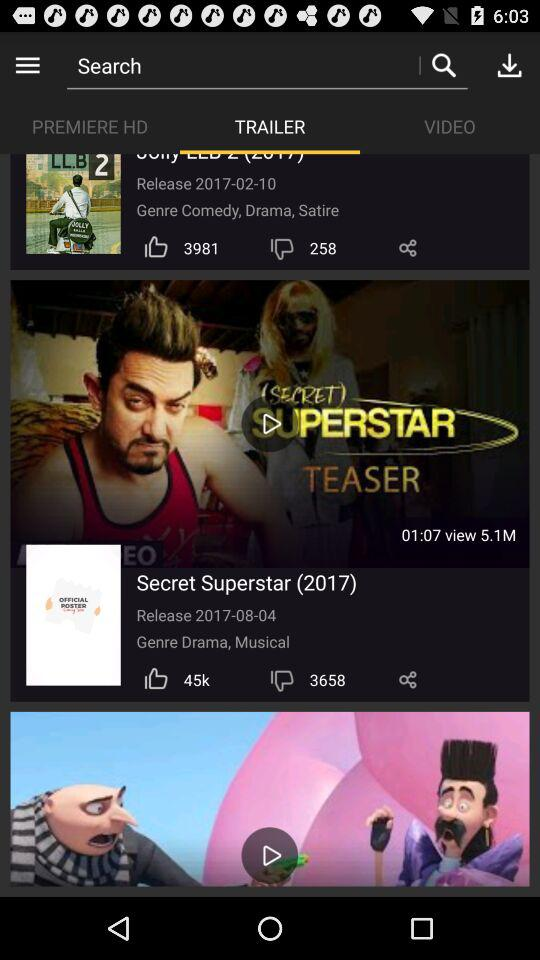What is the release date of the Secret Superstar? The release date is 2017-08-04. 